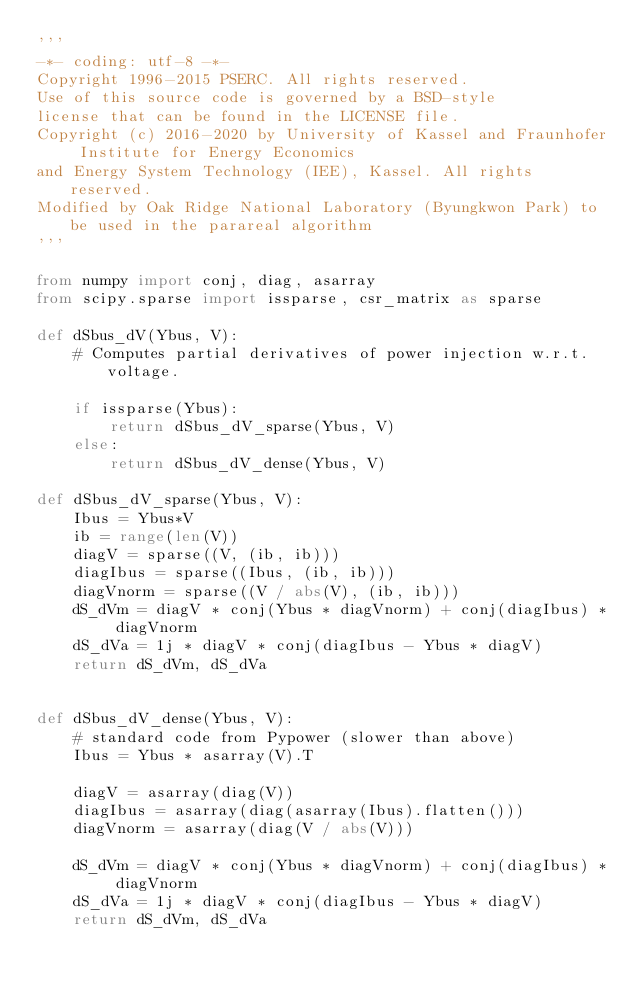<code> <loc_0><loc_0><loc_500><loc_500><_Python_>'''
-*- coding: utf-8 -*-
Copyright 1996-2015 PSERC. All rights reserved.
Use of this source code is governed by a BSD-style
license that can be found in the LICENSE file.
Copyright (c) 2016-2020 by University of Kassel and Fraunhofer Institute for Energy Economics
and Energy System Technology (IEE), Kassel. All rights reserved.
Modified by Oak Ridge National Laboratory (Byungkwon Park) to be used in the parareal algorithm
'''

from numpy import conj, diag, asarray
from scipy.sparse import issparse, csr_matrix as sparse

def dSbus_dV(Ybus, V):
    # Computes partial derivatives of power injection w.r.t. voltage.

    if issparse(Ybus):
        return dSbus_dV_sparse(Ybus, V)
    else:
        return dSbus_dV_dense(Ybus, V)

def dSbus_dV_sparse(Ybus, V):
    Ibus = Ybus*V
    ib = range(len(V))
    diagV = sparse((V, (ib, ib)))
    diagIbus = sparse((Ibus, (ib, ib)))
    diagVnorm = sparse((V / abs(V), (ib, ib)))
    dS_dVm = diagV * conj(Ybus * diagVnorm) + conj(diagIbus) * diagVnorm
    dS_dVa = 1j * diagV * conj(diagIbus - Ybus * diagV)
    return dS_dVm, dS_dVa


def dSbus_dV_dense(Ybus, V):
    # standard code from Pypower (slower than above)
    Ibus = Ybus * asarray(V).T

    diagV = asarray(diag(V))
    diagIbus = asarray(diag(asarray(Ibus).flatten()))
    diagVnorm = asarray(diag(V / abs(V)))

    dS_dVm = diagV * conj(Ybus * diagVnorm) + conj(diagIbus) * diagVnorm
    dS_dVa = 1j * diagV * conj(diagIbus - Ybus * diagV)
    return dS_dVm, dS_dVa
</code> 